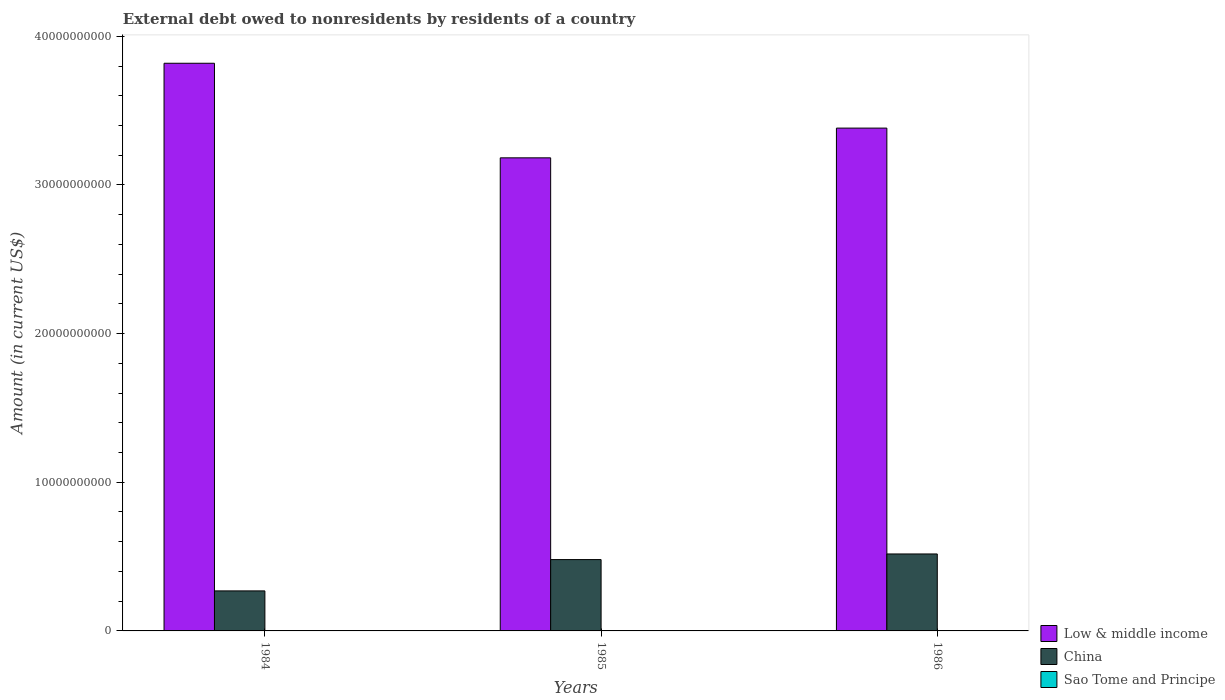How many groups of bars are there?
Offer a very short reply. 3. How many bars are there on the 3rd tick from the left?
Your response must be concise. 3. What is the label of the 2nd group of bars from the left?
Your response must be concise. 1985. What is the external debt owed by residents in China in 1986?
Provide a succinct answer. 5.18e+09. Across all years, what is the maximum external debt owed by residents in China?
Your response must be concise. 5.18e+09. Across all years, what is the minimum external debt owed by residents in Sao Tome and Principe?
Your answer should be very brief. 7.23e+06. What is the total external debt owed by residents in Low & middle income in the graph?
Provide a succinct answer. 1.04e+11. What is the difference between the external debt owed by residents in Low & middle income in 1984 and that in 1985?
Give a very brief answer. 6.36e+09. What is the difference between the external debt owed by residents in Sao Tome and Principe in 1986 and the external debt owed by residents in Low & middle income in 1984?
Offer a very short reply. -3.82e+1. What is the average external debt owed by residents in China per year?
Give a very brief answer. 4.22e+09. In the year 1984, what is the difference between the external debt owed by residents in China and external debt owed by residents in Low & middle income?
Make the answer very short. -3.55e+1. In how many years, is the external debt owed by residents in Low & middle income greater than 26000000000 US$?
Make the answer very short. 3. What is the ratio of the external debt owed by residents in China in 1985 to that in 1986?
Offer a terse response. 0.93. Is the external debt owed by residents in Low & middle income in 1984 less than that in 1985?
Give a very brief answer. No. Is the difference between the external debt owed by residents in China in 1984 and 1985 greater than the difference between the external debt owed by residents in Low & middle income in 1984 and 1985?
Provide a short and direct response. No. What is the difference between the highest and the second highest external debt owed by residents in Low & middle income?
Provide a short and direct response. 4.36e+09. What is the difference between the highest and the lowest external debt owed by residents in China?
Your answer should be compact. 2.48e+09. Is the sum of the external debt owed by residents in Low & middle income in 1984 and 1985 greater than the maximum external debt owed by residents in Sao Tome and Principe across all years?
Offer a very short reply. Yes. Is it the case that in every year, the sum of the external debt owed by residents in China and external debt owed by residents in Low & middle income is greater than the external debt owed by residents in Sao Tome and Principe?
Make the answer very short. Yes. How many bars are there?
Offer a very short reply. 9. What is the difference between two consecutive major ticks on the Y-axis?
Your response must be concise. 1.00e+1. Are the values on the major ticks of Y-axis written in scientific E-notation?
Your response must be concise. No. Does the graph contain any zero values?
Offer a terse response. No. How are the legend labels stacked?
Ensure brevity in your answer.  Vertical. What is the title of the graph?
Keep it short and to the point. External debt owed to nonresidents by residents of a country. Does "Paraguay" appear as one of the legend labels in the graph?
Give a very brief answer. No. What is the label or title of the X-axis?
Keep it short and to the point. Years. What is the label or title of the Y-axis?
Provide a short and direct response. Amount (in current US$). What is the Amount (in current US$) of Low & middle income in 1984?
Offer a terse response. 3.82e+1. What is the Amount (in current US$) of China in 1984?
Offer a terse response. 2.69e+09. What is the Amount (in current US$) of Sao Tome and Principe in 1984?
Your answer should be very brief. 1.26e+07. What is the Amount (in current US$) in Low & middle income in 1985?
Ensure brevity in your answer.  3.18e+1. What is the Amount (in current US$) in China in 1985?
Offer a very short reply. 4.80e+09. What is the Amount (in current US$) of Sao Tome and Principe in 1985?
Keep it short and to the point. 7.23e+06. What is the Amount (in current US$) in Low & middle income in 1986?
Make the answer very short. 3.38e+1. What is the Amount (in current US$) in China in 1986?
Make the answer very short. 5.18e+09. What is the Amount (in current US$) of Sao Tome and Principe in 1986?
Make the answer very short. 1.22e+07. Across all years, what is the maximum Amount (in current US$) of Low & middle income?
Your answer should be compact. 3.82e+1. Across all years, what is the maximum Amount (in current US$) of China?
Ensure brevity in your answer.  5.18e+09. Across all years, what is the maximum Amount (in current US$) in Sao Tome and Principe?
Your answer should be compact. 1.26e+07. Across all years, what is the minimum Amount (in current US$) of Low & middle income?
Your answer should be compact. 3.18e+1. Across all years, what is the minimum Amount (in current US$) of China?
Your response must be concise. 2.69e+09. Across all years, what is the minimum Amount (in current US$) of Sao Tome and Principe?
Your answer should be compact. 7.23e+06. What is the total Amount (in current US$) in Low & middle income in the graph?
Keep it short and to the point. 1.04e+11. What is the total Amount (in current US$) in China in the graph?
Your answer should be very brief. 1.27e+1. What is the total Amount (in current US$) of Sao Tome and Principe in the graph?
Offer a very short reply. 3.20e+07. What is the difference between the Amount (in current US$) in Low & middle income in 1984 and that in 1985?
Offer a terse response. 6.36e+09. What is the difference between the Amount (in current US$) of China in 1984 and that in 1985?
Offer a very short reply. -2.11e+09. What is the difference between the Amount (in current US$) in Sao Tome and Principe in 1984 and that in 1985?
Your response must be concise. 5.34e+06. What is the difference between the Amount (in current US$) in Low & middle income in 1984 and that in 1986?
Provide a succinct answer. 4.36e+09. What is the difference between the Amount (in current US$) in China in 1984 and that in 1986?
Your answer should be very brief. -2.48e+09. What is the difference between the Amount (in current US$) in Low & middle income in 1985 and that in 1986?
Offer a very short reply. -2.00e+09. What is the difference between the Amount (in current US$) of China in 1985 and that in 1986?
Give a very brief answer. -3.78e+08. What is the difference between the Amount (in current US$) of Sao Tome and Principe in 1985 and that in 1986?
Your response must be concise. -4.94e+06. What is the difference between the Amount (in current US$) of Low & middle income in 1984 and the Amount (in current US$) of China in 1985?
Make the answer very short. 3.34e+1. What is the difference between the Amount (in current US$) in Low & middle income in 1984 and the Amount (in current US$) in Sao Tome and Principe in 1985?
Offer a terse response. 3.82e+1. What is the difference between the Amount (in current US$) in China in 1984 and the Amount (in current US$) in Sao Tome and Principe in 1985?
Make the answer very short. 2.69e+09. What is the difference between the Amount (in current US$) of Low & middle income in 1984 and the Amount (in current US$) of China in 1986?
Offer a very short reply. 3.30e+1. What is the difference between the Amount (in current US$) in Low & middle income in 1984 and the Amount (in current US$) in Sao Tome and Principe in 1986?
Your response must be concise. 3.82e+1. What is the difference between the Amount (in current US$) in China in 1984 and the Amount (in current US$) in Sao Tome and Principe in 1986?
Keep it short and to the point. 2.68e+09. What is the difference between the Amount (in current US$) of Low & middle income in 1985 and the Amount (in current US$) of China in 1986?
Offer a very short reply. 2.66e+1. What is the difference between the Amount (in current US$) in Low & middle income in 1985 and the Amount (in current US$) in Sao Tome and Principe in 1986?
Your response must be concise. 3.18e+1. What is the difference between the Amount (in current US$) in China in 1985 and the Amount (in current US$) in Sao Tome and Principe in 1986?
Your response must be concise. 4.79e+09. What is the average Amount (in current US$) of Low & middle income per year?
Make the answer very short. 3.46e+1. What is the average Amount (in current US$) of China per year?
Make the answer very short. 4.22e+09. What is the average Amount (in current US$) of Sao Tome and Principe per year?
Make the answer very short. 1.07e+07. In the year 1984, what is the difference between the Amount (in current US$) of Low & middle income and Amount (in current US$) of China?
Offer a very short reply. 3.55e+1. In the year 1984, what is the difference between the Amount (in current US$) in Low & middle income and Amount (in current US$) in Sao Tome and Principe?
Give a very brief answer. 3.82e+1. In the year 1984, what is the difference between the Amount (in current US$) in China and Amount (in current US$) in Sao Tome and Principe?
Ensure brevity in your answer.  2.68e+09. In the year 1985, what is the difference between the Amount (in current US$) in Low & middle income and Amount (in current US$) in China?
Offer a terse response. 2.70e+1. In the year 1985, what is the difference between the Amount (in current US$) in Low & middle income and Amount (in current US$) in Sao Tome and Principe?
Offer a very short reply. 3.18e+1. In the year 1985, what is the difference between the Amount (in current US$) in China and Amount (in current US$) in Sao Tome and Principe?
Your answer should be very brief. 4.79e+09. In the year 1986, what is the difference between the Amount (in current US$) of Low & middle income and Amount (in current US$) of China?
Your answer should be compact. 2.86e+1. In the year 1986, what is the difference between the Amount (in current US$) in Low & middle income and Amount (in current US$) in Sao Tome and Principe?
Make the answer very short. 3.38e+1. In the year 1986, what is the difference between the Amount (in current US$) in China and Amount (in current US$) in Sao Tome and Principe?
Your answer should be very brief. 5.17e+09. What is the ratio of the Amount (in current US$) of Low & middle income in 1984 to that in 1985?
Your answer should be compact. 1.2. What is the ratio of the Amount (in current US$) in China in 1984 to that in 1985?
Your response must be concise. 0.56. What is the ratio of the Amount (in current US$) of Sao Tome and Principe in 1984 to that in 1985?
Keep it short and to the point. 1.74. What is the ratio of the Amount (in current US$) in Low & middle income in 1984 to that in 1986?
Your answer should be compact. 1.13. What is the ratio of the Amount (in current US$) of China in 1984 to that in 1986?
Provide a succinct answer. 0.52. What is the ratio of the Amount (in current US$) of Sao Tome and Principe in 1984 to that in 1986?
Your response must be concise. 1.03. What is the ratio of the Amount (in current US$) in Low & middle income in 1985 to that in 1986?
Provide a short and direct response. 0.94. What is the ratio of the Amount (in current US$) of China in 1985 to that in 1986?
Give a very brief answer. 0.93. What is the ratio of the Amount (in current US$) of Sao Tome and Principe in 1985 to that in 1986?
Provide a short and direct response. 0.59. What is the difference between the highest and the second highest Amount (in current US$) in Low & middle income?
Your answer should be very brief. 4.36e+09. What is the difference between the highest and the second highest Amount (in current US$) in China?
Provide a succinct answer. 3.78e+08. What is the difference between the highest and the lowest Amount (in current US$) of Low & middle income?
Provide a short and direct response. 6.36e+09. What is the difference between the highest and the lowest Amount (in current US$) of China?
Keep it short and to the point. 2.48e+09. What is the difference between the highest and the lowest Amount (in current US$) in Sao Tome and Principe?
Your answer should be compact. 5.34e+06. 